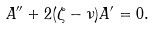<formula> <loc_0><loc_0><loc_500><loc_500>A ^ { \prime \prime } + 2 ( \zeta - \nu ) A ^ { \prime } = 0 .</formula> 